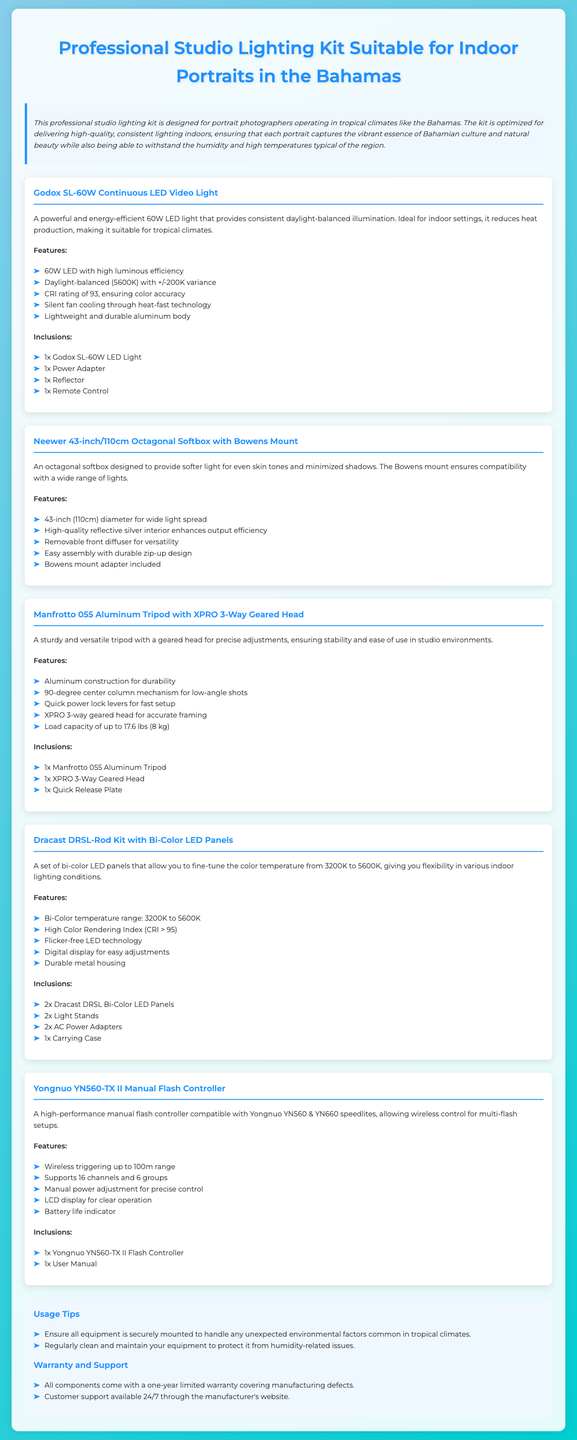What is the model of the continuous LED video light? The document specifies that the continuous LED video light is the Godox SL-60W.
Answer: Godox SL-60W What is the diameter of the octagonal softbox? The Neewer 43-inch/110cm Octagonal Softbox has a diameter of 43 inches (110cm).
Answer: 43 inches What is the load capacity of the Manfrotto tripod? The load capacity of the Manfrotto tripod is specified as up to 17.6 lbs (8 kg).
Answer: 17.6 lbs What is the color temperature range of the Dracast LED panels? The Dracast DRSL-Rod Kit allows color temperature adjustments from 3200K to 5600K.
Answer: 3200K to 5600K How many channels does the Yongnuo flash controller support? The Yongnuo YN560-TX II flash controller supports 16 channels.
Answer: 16 channels What is the warranty period for the components? The components have a one-year limited warranty covering manufacturing defects.
Answer: One year What type of cooling technology does the Godox SL-60W use? The cooling technology used is described as silent fan cooling through heat-fast technology.
Answer: Silent fan cooling What is the main benefit of the octagonal softbox design? The softbox is designed to provide softer light for even skin tones and minimized shadows.
Answer: Softer light for even skin tones How many light stands are included in the Dracast kit? The Dracast kit includes 2 light stands.
Answer: 2 light stands 